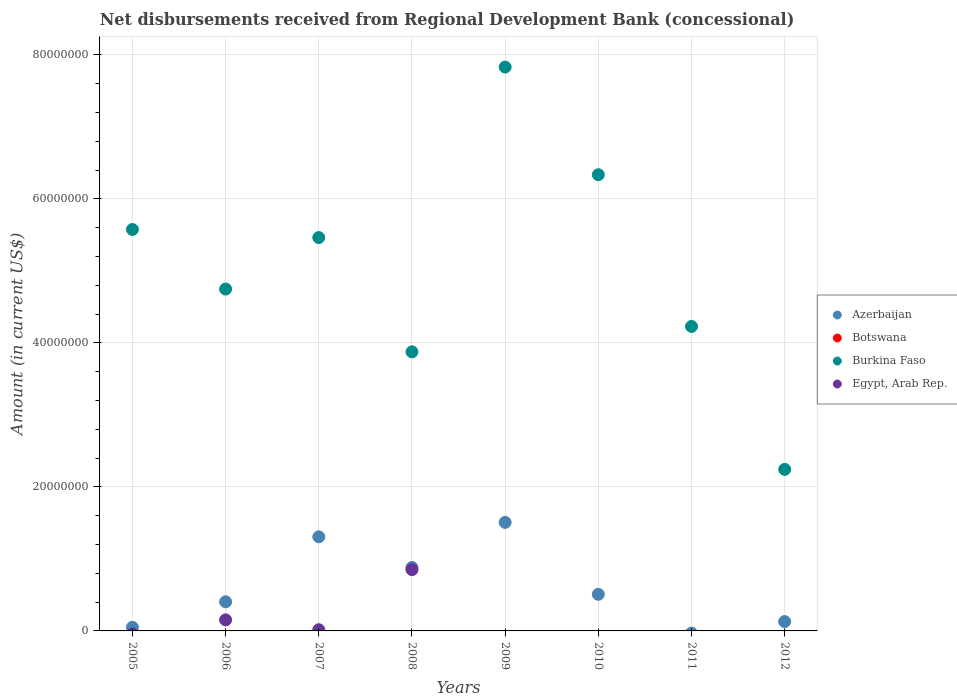What is the amount of disbursements received from Regional Development Bank in Egypt, Arab Rep. in 2011?
Provide a short and direct response. 0. Across all years, what is the maximum amount of disbursements received from Regional Development Bank in Burkina Faso?
Offer a terse response. 7.83e+07. In which year was the amount of disbursements received from Regional Development Bank in Azerbaijan maximum?
Make the answer very short. 2009. What is the difference between the amount of disbursements received from Regional Development Bank in Burkina Faso in 2005 and that in 2012?
Your response must be concise. 3.33e+07. What is the difference between the amount of disbursements received from Regional Development Bank in Botswana in 2012 and the amount of disbursements received from Regional Development Bank in Burkina Faso in 2008?
Your answer should be very brief. -3.88e+07. What is the average amount of disbursements received from Regional Development Bank in Egypt, Arab Rep. per year?
Your response must be concise. 1.28e+06. In the year 2008, what is the difference between the amount of disbursements received from Regional Development Bank in Burkina Faso and amount of disbursements received from Regional Development Bank in Azerbaijan?
Keep it short and to the point. 2.99e+07. In how many years, is the amount of disbursements received from Regional Development Bank in Egypt, Arab Rep. greater than 28000000 US$?
Give a very brief answer. 0. What is the ratio of the amount of disbursements received from Regional Development Bank in Azerbaijan in 2005 to that in 2006?
Give a very brief answer. 0.12. Is the amount of disbursements received from Regional Development Bank in Burkina Faso in 2005 less than that in 2010?
Make the answer very short. Yes. What is the difference between the highest and the second highest amount of disbursements received from Regional Development Bank in Egypt, Arab Rep.?
Provide a succinct answer. 6.97e+06. What is the difference between the highest and the lowest amount of disbursements received from Regional Development Bank in Egypt, Arab Rep.?
Your response must be concise. 8.51e+06. In how many years, is the amount of disbursements received from Regional Development Bank in Burkina Faso greater than the average amount of disbursements received from Regional Development Bank in Burkina Faso taken over all years?
Ensure brevity in your answer.  4. Is the amount of disbursements received from Regional Development Bank in Egypt, Arab Rep. strictly greater than the amount of disbursements received from Regional Development Bank in Azerbaijan over the years?
Your response must be concise. No. How many dotlines are there?
Ensure brevity in your answer.  3. Are the values on the major ticks of Y-axis written in scientific E-notation?
Your answer should be compact. No. Does the graph contain grids?
Your answer should be very brief. Yes. How many legend labels are there?
Offer a terse response. 4. What is the title of the graph?
Ensure brevity in your answer.  Net disbursements received from Regional Development Bank (concessional). What is the label or title of the X-axis?
Ensure brevity in your answer.  Years. What is the Amount (in current US$) of Azerbaijan in 2005?
Your response must be concise. 5.03e+05. What is the Amount (in current US$) of Botswana in 2005?
Keep it short and to the point. 0. What is the Amount (in current US$) in Burkina Faso in 2005?
Your answer should be very brief. 5.58e+07. What is the Amount (in current US$) in Azerbaijan in 2006?
Give a very brief answer. 4.04e+06. What is the Amount (in current US$) of Botswana in 2006?
Keep it short and to the point. 0. What is the Amount (in current US$) in Burkina Faso in 2006?
Your answer should be compact. 4.75e+07. What is the Amount (in current US$) of Egypt, Arab Rep. in 2006?
Give a very brief answer. 1.54e+06. What is the Amount (in current US$) in Azerbaijan in 2007?
Offer a terse response. 1.31e+07. What is the Amount (in current US$) of Burkina Faso in 2007?
Provide a succinct answer. 5.46e+07. What is the Amount (in current US$) of Egypt, Arab Rep. in 2007?
Your answer should be compact. 1.67e+05. What is the Amount (in current US$) of Azerbaijan in 2008?
Your answer should be very brief. 8.81e+06. What is the Amount (in current US$) in Burkina Faso in 2008?
Provide a short and direct response. 3.88e+07. What is the Amount (in current US$) of Egypt, Arab Rep. in 2008?
Offer a terse response. 8.51e+06. What is the Amount (in current US$) of Azerbaijan in 2009?
Your response must be concise. 1.51e+07. What is the Amount (in current US$) in Botswana in 2009?
Offer a very short reply. 0. What is the Amount (in current US$) in Burkina Faso in 2009?
Your answer should be compact. 7.83e+07. What is the Amount (in current US$) in Azerbaijan in 2010?
Provide a succinct answer. 5.08e+06. What is the Amount (in current US$) of Botswana in 2010?
Give a very brief answer. 0. What is the Amount (in current US$) in Burkina Faso in 2010?
Ensure brevity in your answer.  6.34e+07. What is the Amount (in current US$) in Botswana in 2011?
Ensure brevity in your answer.  0. What is the Amount (in current US$) of Burkina Faso in 2011?
Your answer should be very brief. 4.23e+07. What is the Amount (in current US$) in Azerbaijan in 2012?
Your answer should be compact. 1.30e+06. What is the Amount (in current US$) in Botswana in 2012?
Make the answer very short. 0. What is the Amount (in current US$) in Burkina Faso in 2012?
Make the answer very short. 2.24e+07. What is the Amount (in current US$) of Egypt, Arab Rep. in 2012?
Keep it short and to the point. 0. Across all years, what is the maximum Amount (in current US$) of Azerbaijan?
Provide a short and direct response. 1.51e+07. Across all years, what is the maximum Amount (in current US$) of Burkina Faso?
Your answer should be compact. 7.83e+07. Across all years, what is the maximum Amount (in current US$) of Egypt, Arab Rep.?
Make the answer very short. 8.51e+06. Across all years, what is the minimum Amount (in current US$) in Azerbaijan?
Your response must be concise. 0. Across all years, what is the minimum Amount (in current US$) of Burkina Faso?
Make the answer very short. 2.24e+07. What is the total Amount (in current US$) in Azerbaijan in the graph?
Offer a terse response. 4.79e+07. What is the total Amount (in current US$) in Botswana in the graph?
Your answer should be very brief. 0. What is the total Amount (in current US$) in Burkina Faso in the graph?
Your answer should be compact. 4.03e+08. What is the total Amount (in current US$) in Egypt, Arab Rep. in the graph?
Make the answer very short. 1.02e+07. What is the difference between the Amount (in current US$) of Azerbaijan in 2005 and that in 2006?
Keep it short and to the point. -3.54e+06. What is the difference between the Amount (in current US$) of Burkina Faso in 2005 and that in 2006?
Ensure brevity in your answer.  8.28e+06. What is the difference between the Amount (in current US$) of Azerbaijan in 2005 and that in 2007?
Provide a short and direct response. -1.26e+07. What is the difference between the Amount (in current US$) of Burkina Faso in 2005 and that in 2007?
Your answer should be very brief. 1.12e+06. What is the difference between the Amount (in current US$) in Azerbaijan in 2005 and that in 2008?
Offer a very short reply. -8.31e+06. What is the difference between the Amount (in current US$) of Burkina Faso in 2005 and that in 2008?
Provide a succinct answer. 1.70e+07. What is the difference between the Amount (in current US$) in Azerbaijan in 2005 and that in 2009?
Make the answer very short. -1.46e+07. What is the difference between the Amount (in current US$) of Burkina Faso in 2005 and that in 2009?
Ensure brevity in your answer.  -2.26e+07. What is the difference between the Amount (in current US$) of Azerbaijan in 2005 and that in 2010?
Provide a succinct answer. -4.58e+06. What is the difference between the Amount (in current US$) of Burkina Faso in 2005 and that in 2010?
Ensure brevity in your answer.  -7.61e+06. What is the difference between the Amount (in current US$) in Burkina Faso in 2005 and that in 2011?
Offer a terse response. 1.35e+07. What is the difference between the Amount (in current US$) of Azerbaijan in 2005 and that in 2012?
Your response must be concise. -7.94e+05. What is the difference between the Amount (in current US$) in Burkina Faso in 2005 and that in 2012?
Make the answer very short. 3.33e+07. What is the difference between the Amount (in current US$) in Azerbaijan in 2006 and that in 2007?
Your answer should be compact. -9.02e+06. What is the difference between the Amount (in current US$) in Burkina Faso in 2006 and that in 2007?
Your answer should be very brief. -7.16e+06. What is the difference between the Amount (in current US$) of Egypt, Arab Rep. in 2006 and that in 2007?
Your response must be concise. 1.37e+06. What is the difference between the Amount (in current US$) of Azerbaijan in 2006 and that in 2008?
Your answer should be very brief. -4.77e+06. What is the difference between the Amount (in current US$) in Burkina Faso in 2006 and that in 2008?
Your response must be concise. 8.72e+06. What is the difference between the Amount (in current US$) of Egypt, Arab Rep. in 2006 and that in 2008?
Offer a very short reply. -6.97e+06. What is the difference between the Amount (in current US$) of Azerbaijan in 2006 and that in 2009?
Provide a succinct answer. -1.10e+07. What is the difference between the Amount (in current US$) in Burkina Faso in 2006 and that in 2009?
Offer a terse response. -3.08e+07. What is the difference between the Amount (in current US$) in Azerbaijan in 2006 and that in 2010?
Keep it short and to the point. -1.04e+06. What is the difference between the Amount (in current US$) in Burkina Faso in 2006 and that in 2010?
Ensure brevity in your answer.  -1.59e+07. What is the difference between the Amount (in current US$) of Burkina Faso in 2006 and that in 2011?
Provide a short and direct response. 5.19e+06. What is the difference between the Amount (in current US$) in Azerbaijan in 2006 and that in 2012?
Ensure brevity in your answer.  2.75e+06. What is the difference between the Amount (in current US$) of Burkina Faso in 2006 and that in 2012?
Offer a terse response. 2.50e+07. What is the difference between the Amount (in current US$) in Azerbaijan in 2007 and that in 2008?
Your answer should be very brief. 4.26e+06. What is the difference between the Amount (in current US$) in Burkina Faso in 2007 and that in 2008?
Keep it short and to the point. 1.59e+07. What is the difference between the Amount (in current US$) in Egypt, Arab Rep. in 2007 and that in 2008?
Give a very brief answer. -8.34e+06. What is the difference between the Amount (in current US$) of Azerbaijan in 2007 and that in 2009?
Offer a very short reply. -2.00e+06. What is the difference between the Amount (in current US$) of Burkina Faso in 2007 and that in 2009?
Provide a succinct answer. -2.37e+07. What is the difference between the Amount (in current US$) of Azerbaijan in 2007 and that in 2010?
Offer a very short reply. 7.98e+06. What is the difference between the Amount (in current US$) in Burkina Faso in 2007 and that in 2010?
Provide a short and direct response. -8.73e+06. What is the difference between the Amount (in current US$) in Burkina Faso in 2007 and that in 2011?
Your answer should be very brief. 1.23e+07. What is the difference between the Amount (in current US$) of Azerbaijan in 2007 and that in 2012?
Your answer should be compact. 1.18e+07. What is the difference between the Amount (in current US$) of Burkina Faso in 2007 and that in 2012?
Your answer should be compact. 3.22e+07. What is the difference between the Amount (in current US$) of Azerbaijan in 2008 and that in 2009?
Make the answer very short. -6.26e+06. What is the difference between the Amount (in current US$) of Burkina Faso in 2008 and that in 2009?
Your response must be concise. -3.96e+07. What is the difference between the Amount (in current US$) in Azerbaijan in 2008 and that in 2010?
Keep it short and to the point. 3.73e+06. What is the difference between the Amount (in current US$) in Burkina Faso in 2008 and that in 2010?
Your answer should be compact. -2.46e+07. What is the difference between the Amount (in current US$) in Burkina Faso in 2008 and that in 2011?
Provide a succinct answer. -3.53e+06. What is the difference between the Amount (in current US$) in Azerbaijan in 2008 and that in 2012?
Your answer should be compact. 7.52e+06. What is the difference between the Amount (in current US$) of Burkina Faso in 2008 and that in 2012?
Provide a short and direct response. 1.63e+07. What is the difference between the Amount (in current US$) of Azerbaijan in 2009 and that in 2010?
Make the answer very short. 9.99e+06. What is the difference between the Amount (in current US$) in Burkina Faso in 2009 and that in 2010?
Offer a terse response. 1.50e+07. What is the difference between the Amount (in current US$) of Burkina Faso in 2009 and that in 2011?
Keep it short and to the point. 3.60e+07. What is the difference between the Amount (in current US$) of Azerbaijan in 2009 and that in 2012?
Your answer should be very brief. 1.38e+07. What is the difference between the Amount (in current US$) in Burkina Faso in 2009 and that in 2012?
Give a very brief answer. 5.59e+07. What is the difference between the Amount (in current US$) in Burkina Faso in 2010 and that in 2011?
Provide a succinct answer. 2.11e+07. What is the difference between the Amount (in current US$) in Azerbaijan in 2010 and that in 2012?
Ensure brevity in your answer.  3.79e+06. What is the difference between the Amount (in current US$) in Burkina Faso in 2010 and that in 2012?
Offer a very short reply. 4.09e+07. What is the difference between the Amount (in current US$) of Burkina Faso in 2011 and that in 2012?
Provide a succinct answer. 1.99e+07. What is the difference between the Amount (in current US$) of Azerbaijan in 2005 and the Amount (in current US$) of Burkina Faso in 2006?
Give a very brief answer. -4.70e+07. What is the difference between the Amount (in current US$) of Azerbaijan in 2005 and the Amount (in current US$) of Egypt, Arab Rep. in 2006?
Make the answer very short. -1.03e+06. What is the difference between the Amount (in current US$) of Burkina Faso in 2005 and the Amount (in current US$) of Egypt, Arab Rep. in 2006?
Your answer should be very brief. 5.42e+07. What is the difference between the Amount (in current US$) of Azerbaijan in 2005 and the Amount (in current US$) of Burkina Faso in 2007?
Provide a short and direct response. -5.41e+07. What is the difference between the Amount (in current US$) in Azerbaijan in 2005 and the Amount (in current US$) in Egypt, Arab Rep. in 2007?
Keep it short and to the point. 3.36e+05. What is the difference between the Amount (in current US$) in Burkina Faso in 2005 and the Amount (in current US$) in Egypt, Arab Rep. in 2007?
Your response must be concise. 5.56e+07. What is the difference between the Amount (in current US$) of Azerbaijan in 2005 and the Amount (in current US$) of Burkina Faso in 2008?
Provide a short and direct response. -3.83e+07. What is the difference between the Amount (in current US$) in Azerbaijan in 2005 and the Amount (in current US$) in Egypt, Arab Rep. in 2008?
Make the answer very short. -8.00e+06. What is the difference between the Amount (in current US$) in Burkina Faso in 2005 and the Amount (in current US$) in Egypt, Arab Rep. in 2008?
Your answer should be compact. 4.72e+07. What is the difference between the Amount (in current US$) of Azerbaijan in 2005 and the Amount (in current US$) of Burkina Faso in 2009?
Give a very brief answer. -7.78e+07. What is the difference between the Amount (in current US$) of Azerbaijan in 2005 and the Amount (in current US$) of Burkina Faso in 2010?
Ensure brevity in your answer.  -6.29e+07. What is the difference between the Amount (in current US$) of Azerbaijan in 2005 and the Amount (in current US$) of Burkina Faso in 2011?
Your answer should be very brief. -4.18e+07. What is the difference between the Amount (in current US$) in Azerbaijan in 2005 and the Amount (in current US$) in Burkina Faso in 2012?
Your response must be concise. -2.19e+07. What is the difference between the Amount (in current US$) of Azerbaijan in 2006 and the Amount (in current US$) of Burkina Faso in 2007?
Your response must be concise. -5.06e+07. What is the difference between the Amount (in current US$) of Azerbaijan in 2006 and the Amount (in current US$) of Egypt, Arab Rep. in 2007?
Your answer should be very brief. 3.88e+06. What is the difference between the Amount (in current US$) in Burkina Faso in 2006 and the Amount (in current US$) in Egypt, Arab Rep. in 2007?
Offer a terse response. 4.73e+07. What is the difference between the Amount (in current US$) in Azerbaijan in 2006 and the Amount (in current US$) in Burkina Faso in 2008?
Make the answer very short. -3.47e+07. What is the difference between the Amount (in current US$) of Azerbaijan in 2006 and the Amount (in current US$) of Egypt, Arab Rep. in 2008?
Offer a very short reply. -4.46e+06. What is the difference between the Amount (in current US$) of Burkina Faso in 2006 and the Amount (in current US$) of Egypt, Arab Rep. in 2008?
Ensure brevity in your answer.  3.90e+07. What is the difference between the Amount (in current US$) in Azerbaijan in 2006 and the Amount (in current US$) in Burkina Faso in 2009?
Keep it short and to the point. -7.43e+07. What is the difference between the Amount (in current US$) of Azerbaijan in 2006 and the Amount (in current US$) of Burkina Faso in 2010?
Offer a terse response. -5.93e+07. What is the difference between the Amount (in current US$) in Azerbaijan in 2006 and the Amount (in current US$) in Burkina Faso in 2011?
Keep it short and to the point. -3.82e+07. What is the difference between the Amount (in current US$) of Azerbaijan in 2006 and the Amount (in current US$) of Burkina Faso in 2012?
Offer a terse response. -1.84e+07. What is the difference between the Amount (in current US$) in Azerbaijan in 2007 and the Amount (in current US$) in Burkina Faso in 2008?
Ensure brevity in your answer.  -2.57e+07. What is the difference between the Amount (in current US$) of Azerbaijan in 2007 and the Amount (in current US$) of Egypt, Arab Rep. in 2008?
Your answer should be very brief. 4.56e+06. What is the difference between the Amount (in current US$) of Burkina Faso in 2007 and the Amount (in current US$) of Egypt, Arab Rep. in 2008?
Offer a terse response. 4.61e+07. What is the difference between the Amount (in current US$) of Azerbaijan in 2007 and the Amount (in current US$) of Burkina Faso in 2009?
Provide a short and direct response. -6.52e+07. What is the difference between the Amount (in current US$) in Azerbaijan in 2007 and the Amount (in current US$) in Burkina Faso in 2010?
Your answer should be very brief. -5.03e+07. What is the difference between the Amount (in current US$) in Azerbaijan in 2007 and the Amount (in current US$) in Burkina Faso in 2011?
Your answer should be very brief. -2.92e+07. What is the difference between the Amount (in current US$) of Azerbaijan in 2007 and the Amount (in current US$) of Burkina Faso in 2012?
Keep it short and to the point. -9.36e+06. What is the difference between the Amount (in current US$) in Azerbaijan in 2008 and the Amount (in current US$) in Burkina Faso in 2009?
Your response must be concise. -6.95e+07. What is the difference between the Amount (in current US$) in Azerbaijan in 2008 and the Amount (in current US$) in Burkina Faso in 2010?
Keep it short and to the point. -5.45e+07. What is the difference between the Amount (in current US$) in Azerbaijan in 2008 and the Amount (in current US$) in Burkina Faso in 2011?
Ensure brevity in your answer.  -3.35e+07. What is the difference between the Amount (in current US$) of Azerbaijan in 2008 and the Amount (in current US$) of Burkina Faso in 2012?
Offer a terse response. -1.36e+07. What is the difference between the Amount (in current US$) in Azerbaijan in 2009 and the Amount (in current US$) in Burkina Faso in 2010?
Give a very brief answer. -4.83e+07. What is the difference between the Amount (in current US$) of Azerbaijan in 2009 and the Amount (in current US$) of Burkina Faso in 2011?
Your answer should be very brief. -2.72e+07. What is the difference between the Amount (in current US$) in Azerbaijan in 2009 and the Amount (in current US$) in Burkina Faso in 2012?
Offer a terse response. -7.36e+06. What is the difference between the Amount (in current US$) of Azerbaijan in 2010 and the Amount (in current US$) of Burkina Faso in 2011?
Provide a succinct answer. -3.72e+07. What is the difference between the Amount (in current US$) of Azerbaijan in 2010 and the Amount (in current US$) of Burkina Faso in 2012?
Ensure brevity in your answer.  -1.73e+07. What is the average Amount (in current US$) in Azerbaijan per year?
Provide a succinct answer. 5.99e+06. What is the average Amount (in current US$) in Botswana per year?
Keep it short and to the point. 0. What is the average Amount (in current US$) of Burkina Faso per year?
Provide a short and direct response. 5.04e+07. What is the average Amount (in current US$) of Egypt, Arab Rep. per year?
Your answer should be compact. 1.28e+06. In the year 2005, what is the difference between the Amount (in current US$) in Azerbaijan and Amount (in current US$) in Burkina Faso?
Provide a short and direct response. -5.52e+07. In the year 2006, what is the difference between the Amount (in current US$) of Azerbaijan and Amount (in current US$) of Burkina Faso?
Ensure brevity in your answer.  -4.34e+07. In the year 2006, what is the difference between the Amount (in current US$) of Azerbaijan and Amount (in current US$) of Egypt, Arab Rep.?
Make the answer very short. 2.51e+06. In the year 2006, what is the difference between the Amount (in current US$) in Burkina Faso and Amount (in current US$) in Egypt, Arab Rep.?
Provide a short and direct response. 4.59e+07. In the year 2007, what is the difference between the Amount (in current US$) in Azerbaijan and Amount (in current US$) in Burkina Faso?
Your response must be concise. -4.16e+07. In the year 2007, what is the difference between the Amount (in current US$) in Azerbaijan and Amount (in current US$) in Egypt, Arab Rep.?
Your answer should be very brief. 1.29e+07. In the year 2007, what is the difference between the Amount (in current US$) of Burkina Faso and Amount (in current US$) of Egypt, Arab Rep.?
Provide a short and direct response. 5.45e+07. In the year 2008, what is the difference between the Amount (in current US$) of Azerbaijan and Amount (in current US$) of Burkina Faso?
Offer a terse response. -2.99e+07. In the year 2008, what is the difference between the Amount (in current US$) in Azerbaijan and Amount (in current US$) in Egypt, Arab Rep.?
Offer a terse response. 3.07e+05. In the year 2008, what is the difference between the Amount (in current US$) of Burkina Faso and Amount (in current US$) of Egypt, Arab Rep.?
Provide a succinct answer. 3.02e+07. In the year 2009, what is the difference between the Amount (in current US$) in Azerbaijan and Amount (in current US$) in Burkina Faso?
Offer a terse response. -6.32e+07. In the year 2010, what is the difference between the Amount (in current US$) of Azerbaijan and Amount (in current US$) of Burkina Faso?
Offer a terse response. -5.83e+07. In the year 2012, what is the difference between the Amount (in current US$) of Azerbaijan and Amount (in current US$) of Burkina Faso?
Give a very brief answer. -2.11e+07. What is the ratio of the Amount (in current US$) in Azerbaijan in 2005 to that in 2006?
Provide a short and direct response. 0.12. What is the ratio of the Amount (in current US$) of Burkina Faso in 2005 to that in 2006?
Make the answer very short. 1.17. What is the ratio of the Amount (in current US$) in Azerbaijan in 2005 to that in 2007?
Ensure brevity in your answer.  0.04. What is the ratio of the Amount (in current US$) of Burkina Faso in 2005 to that in 2007?
Your answer should be very brief. 1.02. What is the ratio of the Amount (in current US$) in Azerbaijan in 2005 to that in 2008?
Offer a terse response. 0.06. What is the ratio of the Amount (in current US$) of Burkina Faso in 2005 to that in 2008?
Give a very brief answer. 1.44. What is the ratio of the Amount (in current US$) in Azerbaijan in 2005 to that in 2009?
Offer a terse response. 0.03. What is the ratio of the Amount (in current US$) of Burkina Faso in 2005 to that in 2009?
Give a very brief answer. 0.71. What is the ratio of the Amount (in current US$) of Azerbaijan in 2005 to that in 2010?
Provide a succinct answer. 0.1. What is the ratio of the Amount (in current US$) in Burkina Faso in 2005 to that in 2010?
Your answer should be compact. 0.88. What is the ratio of the Amount (in current US$) of Burkina Faso in 2005 to that in 2011?
Give a very brief answer. 1.32. What is the ratio of the Amount (in current US$) of Azerbaijan in 2005 to that in 2012?
Make the answer very short. 0.39. What is the ratio of the Amount (in current US$) in Burkina Faso in 2005 to that in 2012?
Offer a very short reply. 2.49. What is the ratio of the Amount (in current US$) in Azerbaijan in 2006 to that in 2007?
Your answer should be compact. 0.31. What is the ratio of the Amount (in current US$) of Burkina Faso in 2006 to that in 2007?
Your response must be concise. 0.87. What is the ratio of the Amount (in current US$) of Egypt, Arab Rep. in 2006 to that in 2007?
Provide a short and direct response. 9.2. What is the ratio of the Amount (in current US$) of Azerbaijan in 2006 to that in 2008?
Your answer should be very brief. 0.46. What is the ratio of the Amount (in current US$) of Burkina Faso in 2006 to that in 2008?
Your response must be concise. 1.23. What is the ratio of the Amount (in current US$) of Egypt, Arab Rep. in 2006 to that in 2008?
Offer a terse response. 0.18. What is the ratio of the Amount (in current US$) of Azerbaijan in 2006 to that in 2009?
Keep it short and to the point. 0.27. What is the ratio of the Amount (in current US$) in Burkina Faso in 2006 to that in 2009?
Your answer should be very brief. 0.61. What is the ratio of the Amount (in current US$) in Azerbaijan in 2006 to that in 2010?
Give a very brief answer. 0.8. What is the ratio of the Amount (in current US$) of Burkina Faso in 2006 to that in 2010?
Your answer should be very brief. 0.75. What is the ratio of the Amount (in current US$) in Burkina Faso in 2006 to that in 2011?
Give a very brief answer. 1.12. What is the ratio of the Amount (in current US$) in Azerbaijan in 2006 to that in 2012?
Give a very brief answer. 3.12. What is the ratio of the Amount (in current US$) of Burkina Faso in 2006 to that in 2012?
Keep it short and to the point. 2.12. What is the ratio of the Amount (in current US$) of Azerbaijan in 2007 to that in 2008?
Your answer should be compact. 1.48. What is the ratio of the Amount (in current US$) of Burkina Faso in 2007 to that in 2008?
Ensure brevity in your answer.  1.41. What is the ratio of the Amount (in current US$) in Egypt, Arab Rep. in 2007 to that in 2008?
Give a very brief answer. 0.02. What is the ratio of the Amount (in current US$) in Azerbaijan in 2007 to that in 2009?
Make the answer very short. 0.87. What is the ratio of the Amount (in current US$) in Burkina Faso in 2007 to that in 2009?
Keep it short and to the point. 0.7. What is the ratio of the Amount (in current US$) in Azerbaijan in 2007 to that in 2010?
Offer a terse response. 2.57. What is the ratio of the Amount (in current US$) of Burkina Faso in 2007 to that in 2010?
Offer a very short reply. 0.86. What is the ratio of the Amount (in current US$) in Burkina Faso in 2007 to that in 2011?
Your answer should be very brief. 1.29. What is the ratio of the Amount (in current US$) in Azerbaijan in 2007 to that in 2012?
Make the answer very short. 10.08. What is the ratio of the Amount (in current US$) in Burkina Faso in 2007 to that in 2012?
Make the answer very short. 2.44. What is the ratio of the Amount (in current US$) of Azerbaijan in 2008 to that in 2009?
Your answer should be compact. 0.58. What is the ratio of the Amount (in current US$) in Burkina Faso in 2008 to that in 2009?
Ensure brevity in your answer.  0.49. What is the ratio of the Amount (in current US$) of Azerbaijan in 2008 to that in 2010?
Provide a short and direct response. 1.73. What is the ratio of the Amount (in current US$) in Burkina Faso in 2008 to that in 2010?
Your answer should be very brief. 0.61. What is the ratio of the Amount (in current US$) of Burkina Faso in 2008 to that in 2011?
Keep it short and to the point. 0.92. What is the ratio of the Amount (in current US$) in Azerbaijan in 2008 to that in 2012?
Your answer should be very brief. 6.8. What is the ratio of the Amount (in current US$) of Burkina Faso in 2008 to that in 2012?
Offer a terse response. 1.73. What is the ratio of the Amount (in current US$) in Azerbaijan in 2009 to that in 2010?
Your answer should be compact. 2.96. What is the ratio of the Amount (in current US$) of Burkina Faso in 2009 to that in 2010?
Your answer should be compact. 1.24. What is the ratio of the Amount (in current US$) in Burkina Faso in 2009 to that in 2011?
Your answer should be very brief. 1.85. What is the ratio of the Amount (in current US$) in Azerbaijan in 2009 to that in 2012?
Offer a terse response. 11.62. What is the ratio of the Amount (in current US$) in Burkina Faso in 2009 to that in 2012?
Your answer should be very brief. 3.49. What is the ratio of the Amount (in current US$) in Burkina Faso in 2010 to that in 2011?
Keep it short and to the point. 1.5. What is the ratio of the Amount (in current US$) of Azerbaijan in 2010 to that in 2012?
Your response must be concise. 3.92. What is the ratio of the Amount (in current US$) of Burkina Faso in 2010 to that in 2012?
Your answer should be compact. 2.82. What is the ratio of the Amount (in current US$) of Burkina Faso in 2011 to that in 2012?
Offer a terse response. 1.88. What is the difference between the highest and the second highest Amount (in current US$) of Azerbaijan?
Offer a very short reply. 2.00e+06. What is the difference between the highest and the second highest Amount (in current US$) of Burkina Faso?
Ensure brevity in your answer.  1.50e+07. What is the difference between the highest and the second highest Amount (in current US$) of Egypt, Arab Rep.?
Keep it short and to the point. 6.97e+06. What is the difference between the highest and the lowest Amount (in current US$) in Azerbaijan?
Provide a succinct answer. 1.51e+07. What is the difference between the highest and the lowest Amount (in current US$) in Burkina Faso?
Give a very brief answer. 5.59e+07. What is the difference between the highest and the lowest Amount (in current US$) in Egypt, Arab Rep.?
Ensure brevity in your answer.  8.51e+06. 